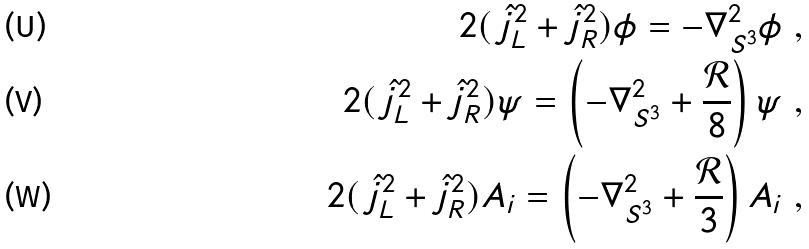Convert formula to latex. <formula><loc_0><loc_0><loc_500><loc_500>2 ( \, \hat { j } _ { L } ^ { 2 } + \hat { j } _ { R } ^ { 2 } ) \phi = - \nabla _ { S ^ { 3 } } ^ { 2 } \phi \ , \\ 2 ( \, \hat { j } _ { L } ^ { 2 } + \hat { j } _ { R } ^ { 2 } ) \psi = \left ( - \nabla _ { S ^ { 3 } } ^ { 2 } + \frac { \mathcal { R } } { 8 } \right ) \psi \ , \\ 2 ( \, \hat { j } _ { L } ^ { 2 } + \hat { j } _ { R } ^ { 2 } ) A _ { i } = \left ( - \nabla _ { S ^ { 3 } } ^ { 2 } + \frac { \mathcal { R } } { 3 } \right ) A _ { i } \ ,</formula> 